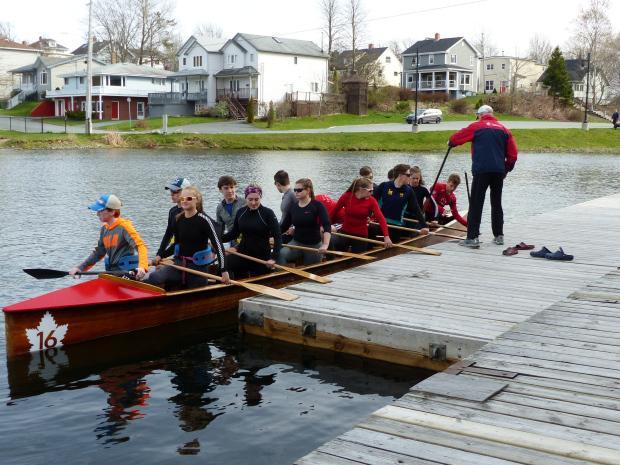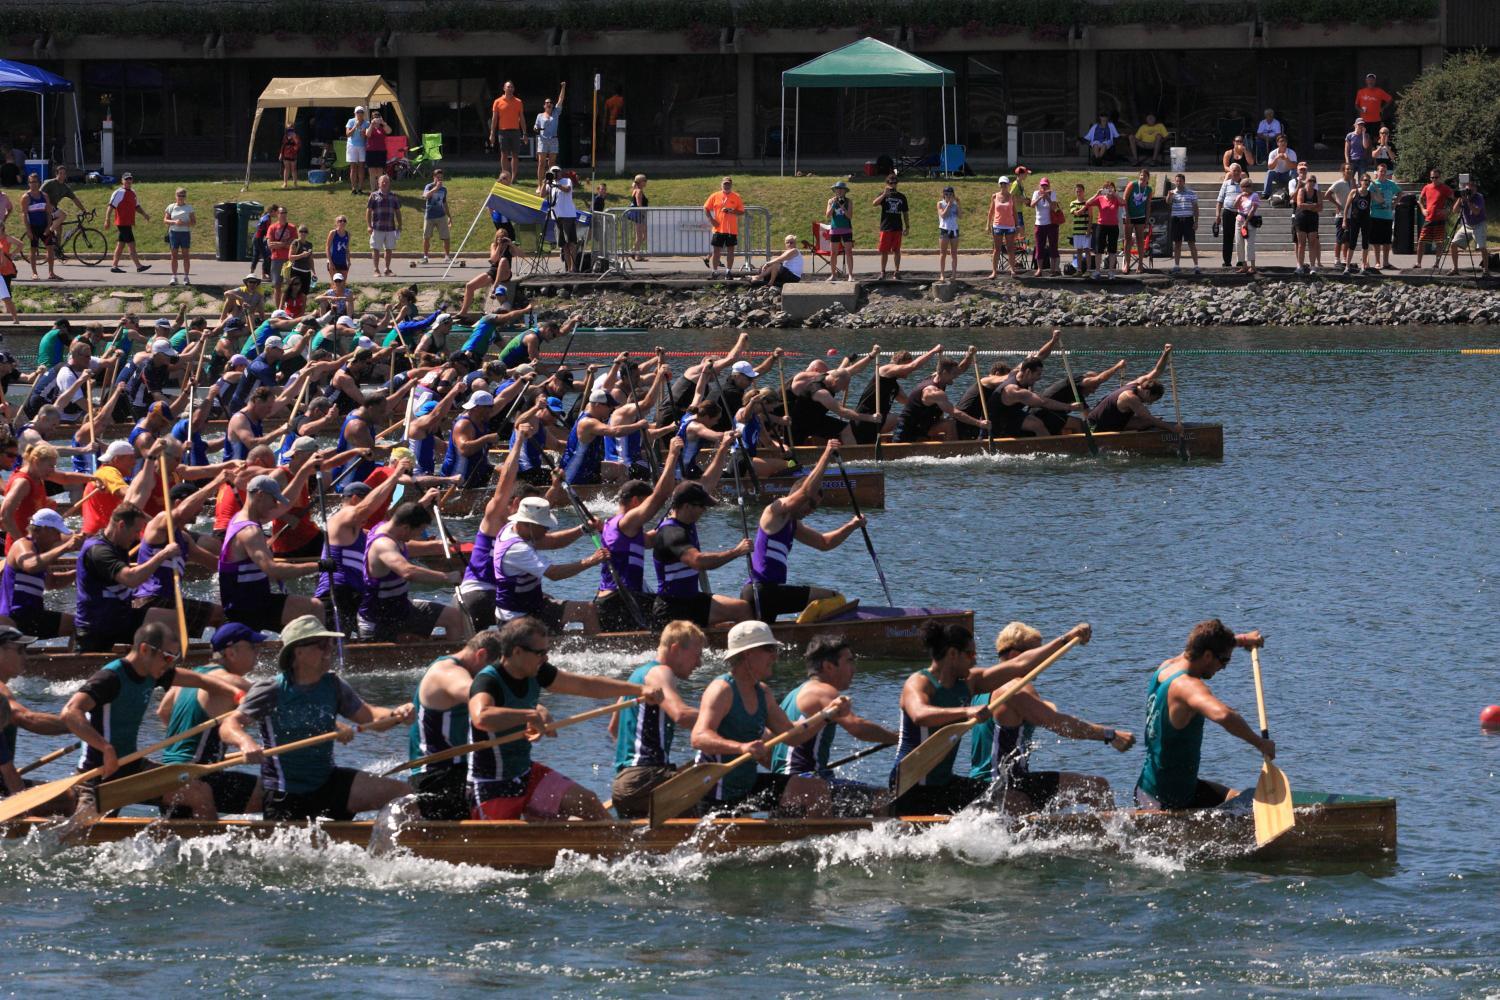The first image is the image on the left, the second image is the image on the right. Analyze the images presented: Is the assertion "In 1 of the images, the oars are kicking up spray." valid? Answer yes or no. Yes. The first image is the image on the left, the second image is the image on the right. Examine the images to the left and right. Is the description "One of the boats is red." accurate? Answer yes or no. Yes. 